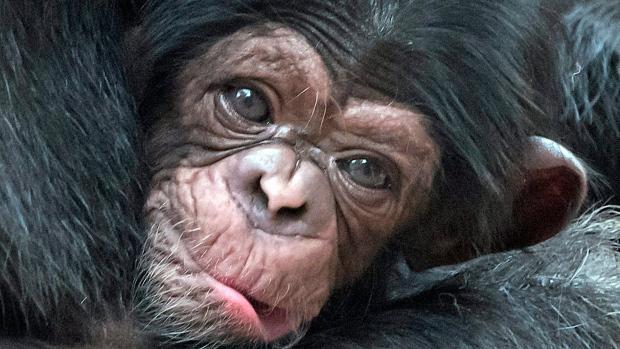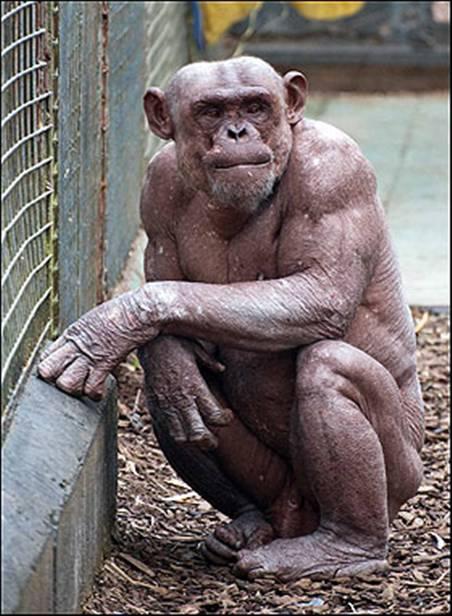The first image is the image on the left, the second image is the image on the right. Examine the images to the left and right. Is the description "An image shows one squatting ape, which is hairless." accurate? Answer yes or no. Yes. The first image is the image on the left, the second image is the image on the right. Examine the images to the left and right. Is the description "There is a single hairless chimp in the right image." accurate? Answer yes or no. Yes. 